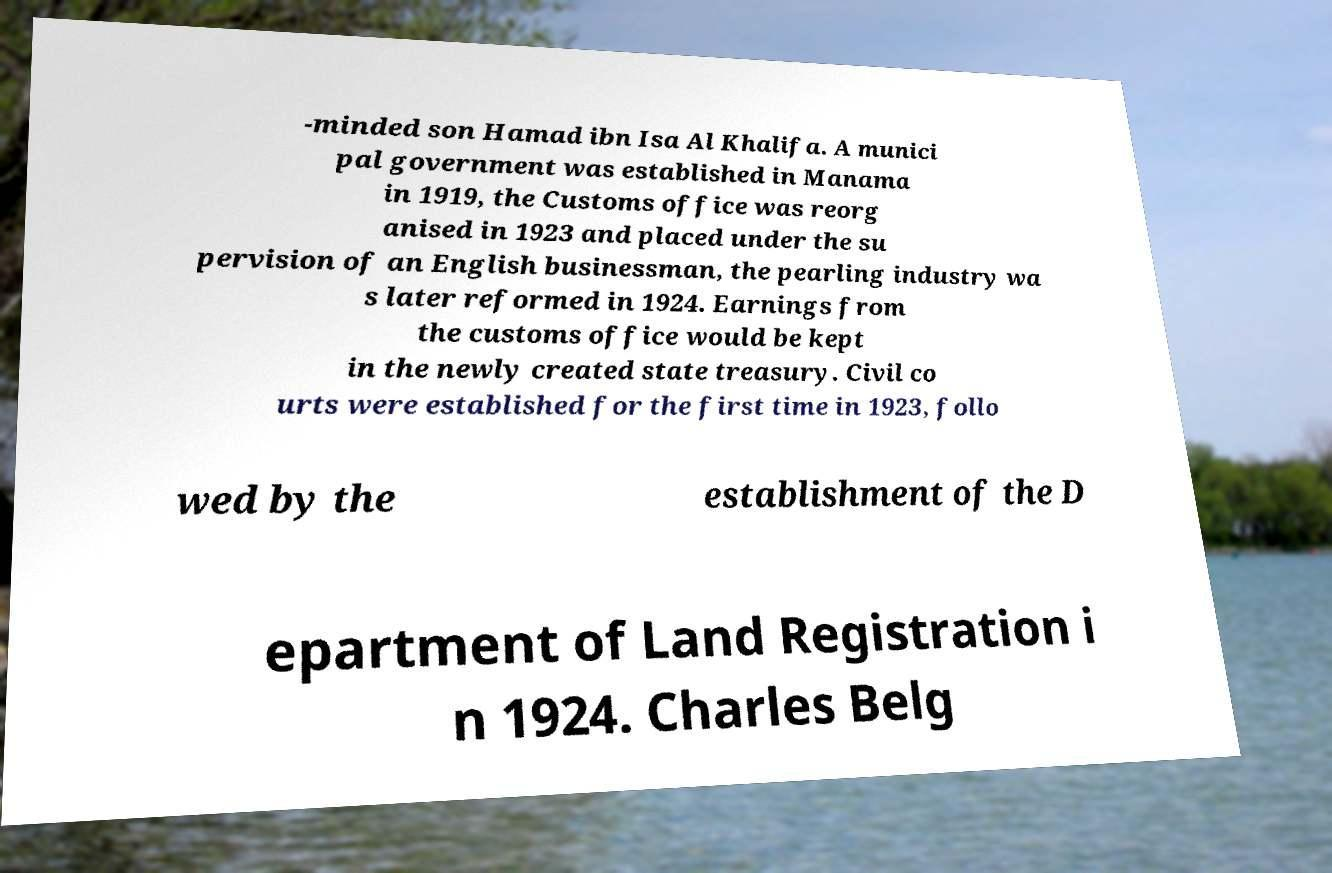For documentation purposes, I need the text within this image transcribed. Could you provide that? -minded son Hamad ibn Isa Al Khalifa. A munici pal government was established in Manama in 1919, the Customs office was reorg anised in 1923 and placed under the su pervision of an English businessman, the pearling industry wa s later reformed in 1924. Earnings from the customs office would be kept in the newly created state treasury. Civil co urts were established for the first time in 1923, follo wed by the establishment of the D epartment of Land Registration i n 1924. Charles Belg 